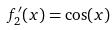Convert formula to latex. <formula><loc_0><loc_0><loc_500><loc_500>f _ { 2 } ^ { \prime } ( x ) = \cos ( x )</formula> 